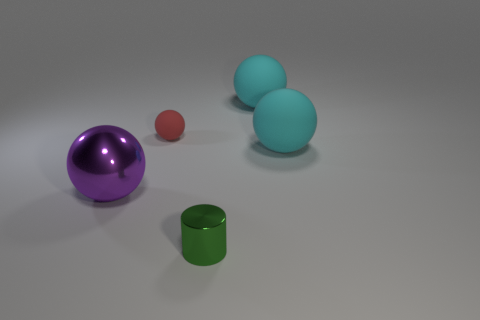If these objects were part of a set, what kind of set could that be? If we were to imagine these objects as part of a set, they could belong to a designer's collection for a modern, minimalist game, perhaps a tactile puzzle set designed to stimulate visual and spatial intelligence. 